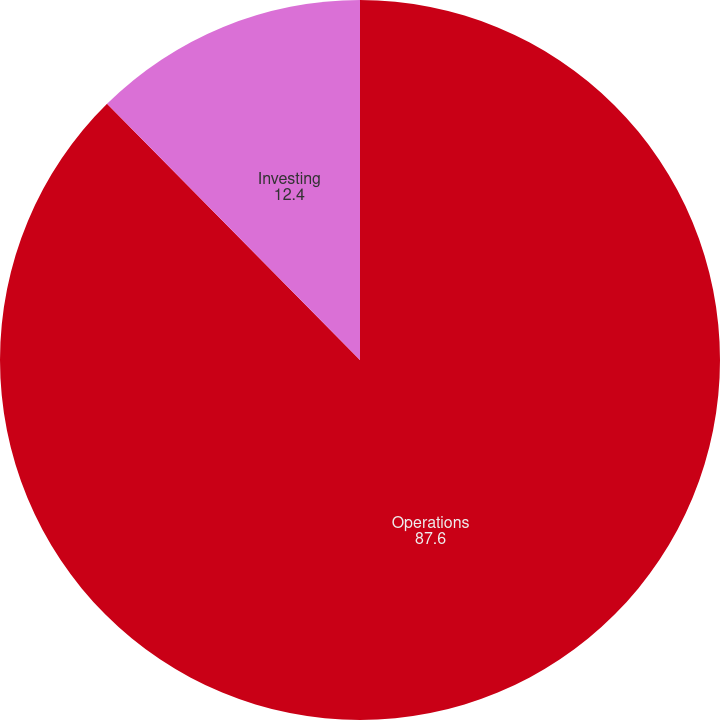Convert chart to OTSL. <chart><loc_0><loc_0><loc_500><loc_500><pie_chart><fcel>Operations<fcel>Investing<nl><fcel>87.6%<fcel>12.4%<nl></chart> 